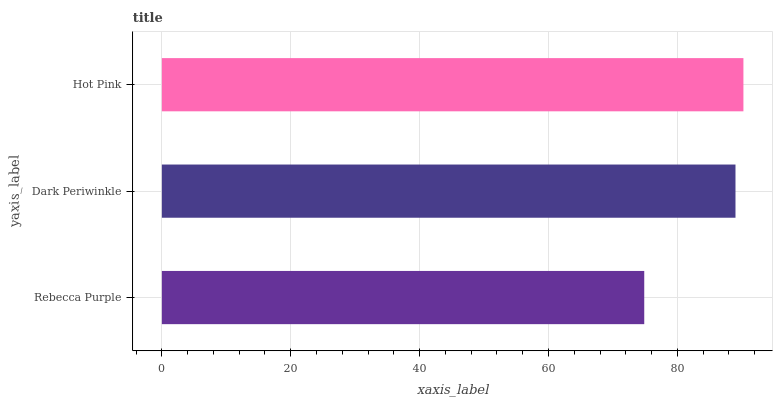Is Rebecca Purple the minimum?
Answer yes or no. Yes. Is Hot Pink the maximum?
Answer yes or no. Yes. Is Dark Periwinkle the minimum?
Answer yes or no. No. Is Dark Periwinkle the maximum?
Answer yes or no. No. Is Dark Periwinkle greater than Rebecca Purple?
Answer yes or no. Yes. Is Rebecca Purple less than Dark Periwinkle?
Answer yes or no. Yes. Is Rebecca Purple greater than Dark Periwinkle?
Answer yes or no. No. Is Dark Periwinkle less than Rebecca Purple?
Answer yes or no. No. Is Dark Periwinkle the high median?
Answer yes or no. Yes. Is Dark Periwinkle the low median?
Answer yes or no. Yes. Is Rebecca Purple the high median?
Answer yes or no. No. Is Rebecca Purple the low median?
Answer yes or no. No. 